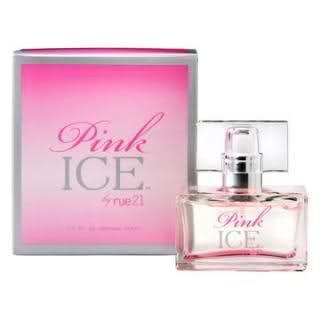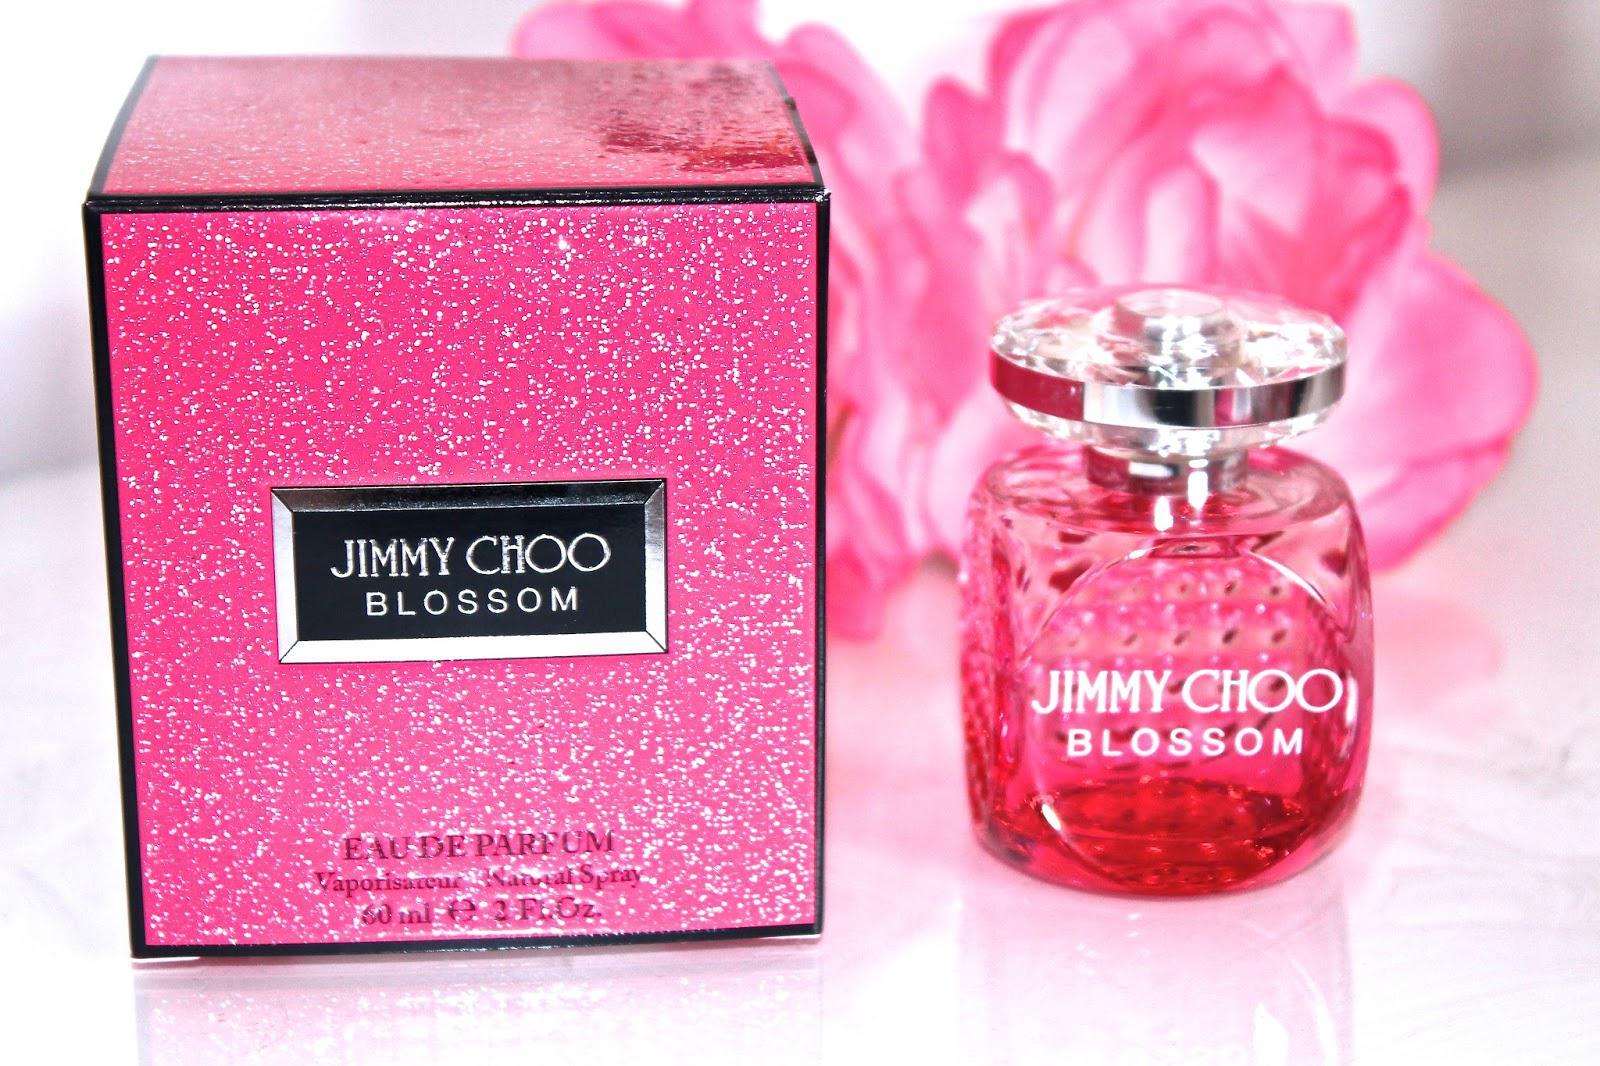The first image is the image on the left, the second image is the image on the right. For the images displayed, is the sentence "There are pink flower petals behind the container in the image on the right." factually correct? Answer yes or no. Yes. The first image is the image on the left, the second image is the image on the right. Assess this claim about the two images: "The right image contains no more than one perfume container.". Correct or not? Answer yes or no. Yes. 